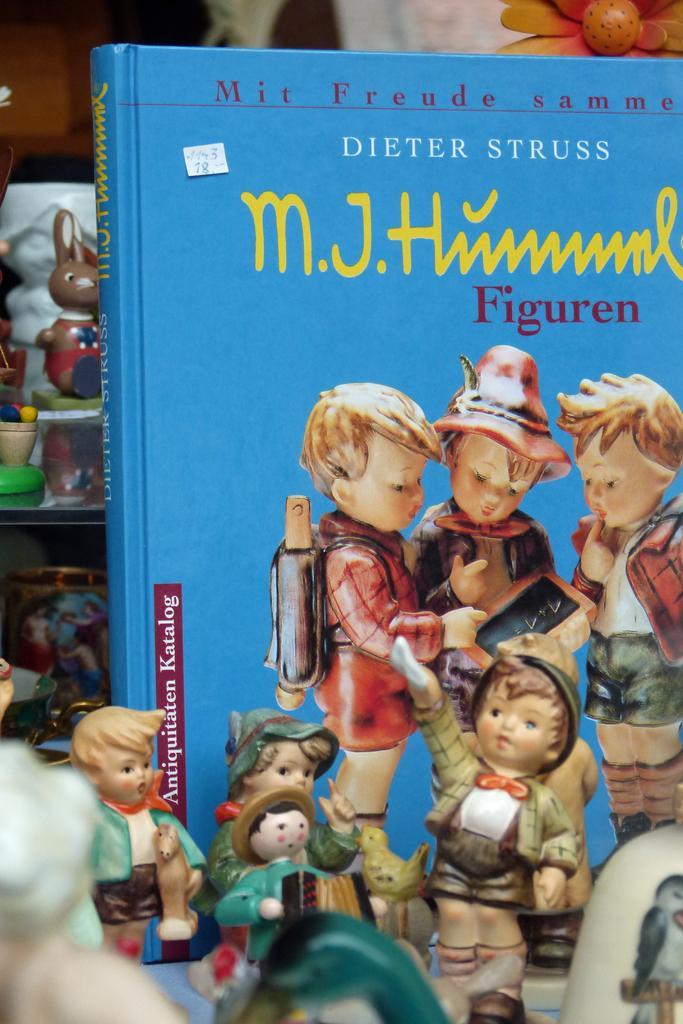Please provide a concise description of this image. There is a blue color book is present on the right side of this image. There are some toys kept at the bottom of this image and on the left side of this image as well. There is a flower at the top right corner of this image. 